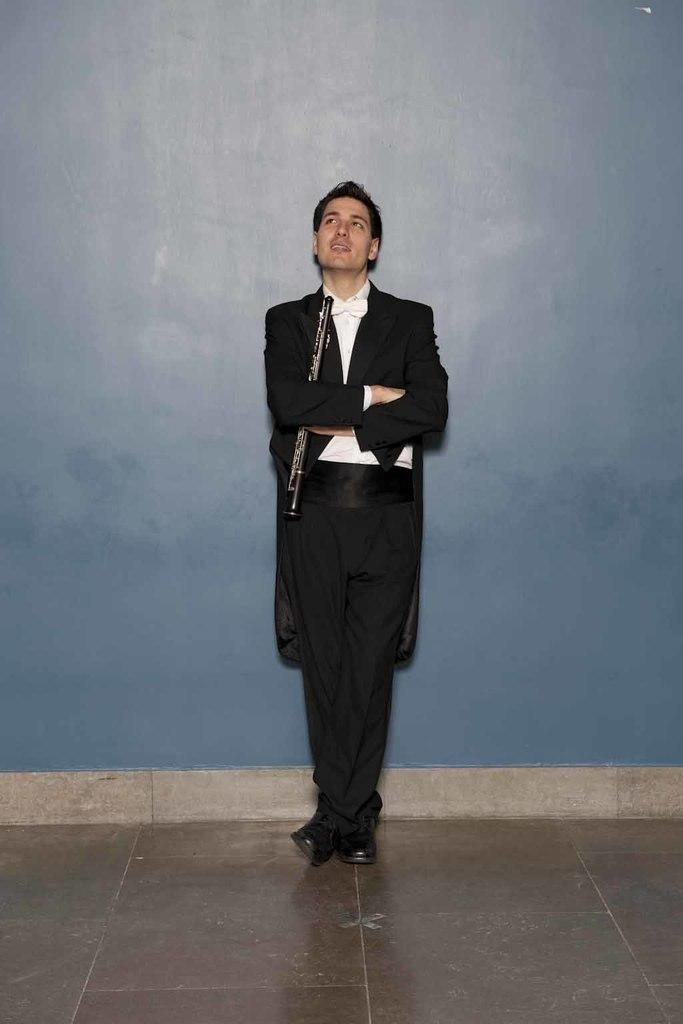What color is the wall in the image? There is a blue wall in the image. What is happening in front of the blue wall? A person is standing in front of the blue wall. What is the person holding in the image? The person is holding an object. What direction is the person looking in the image? The person is looking upwards. What type of drum is the wren playing on the blue wall in the image? There is no drum or wren present in the image. 